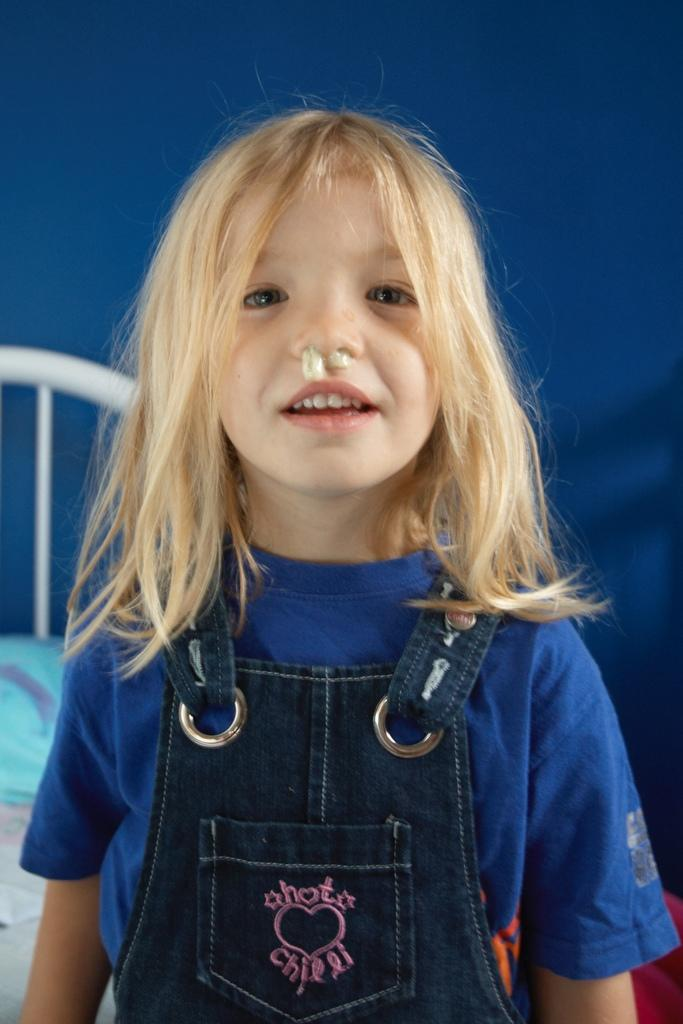What is the main subject of the image? The main subject of the image is a kid. What is the kid doing in the image? The kid is presenting. What type of army is visible in the image? There is no army present in the image; it features a kid presenting. What color is the brick that the kid is holding in the image? There is no brick present in the image. 